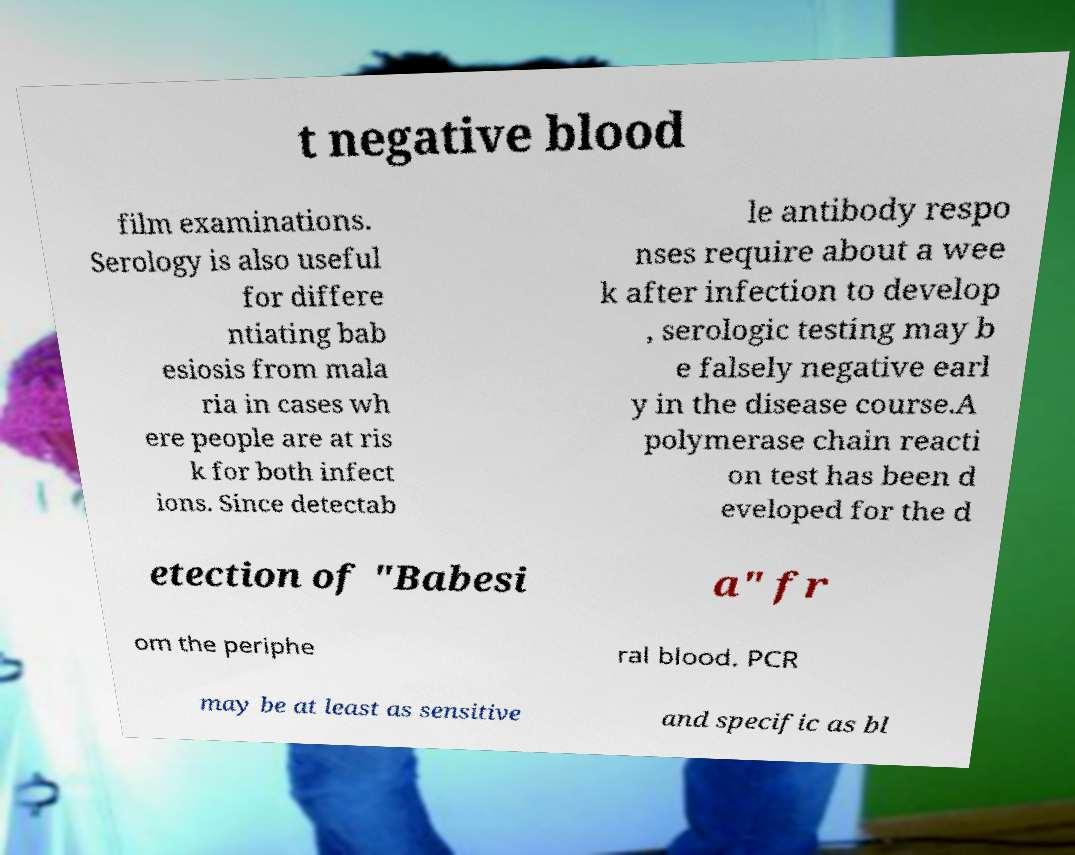There's text embedded in this image that I need extracted. Can you transcribe it verbatim? t negative blood film examinations. Serology is also useful for differe ntiating bab esiosis from mala ria in cases wh ere people are at ris k for both infect ions. Since detectab le antibody respo nses require about a wee k after infection to develop , serologic testing may b e falsely negative earl y in the disease course.A polymerase chain reacti on test has been d eveloped for the d etection of "Babesi a" fr om the periphe ral blood. PCR may be at least as sensitive and specific as bl 